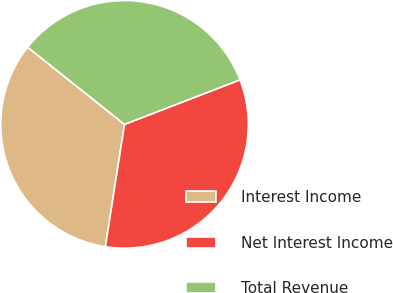Convert chart. <chart><loc_0><loc_0><loc_500><loc_500><pie_chart><fcel>Interest Income<fcel>Net Interest Income<fcel>Total Revenue<nl><fcel>33.23%<fcel>33.33%<fcel>33.44%<nl></chart> 